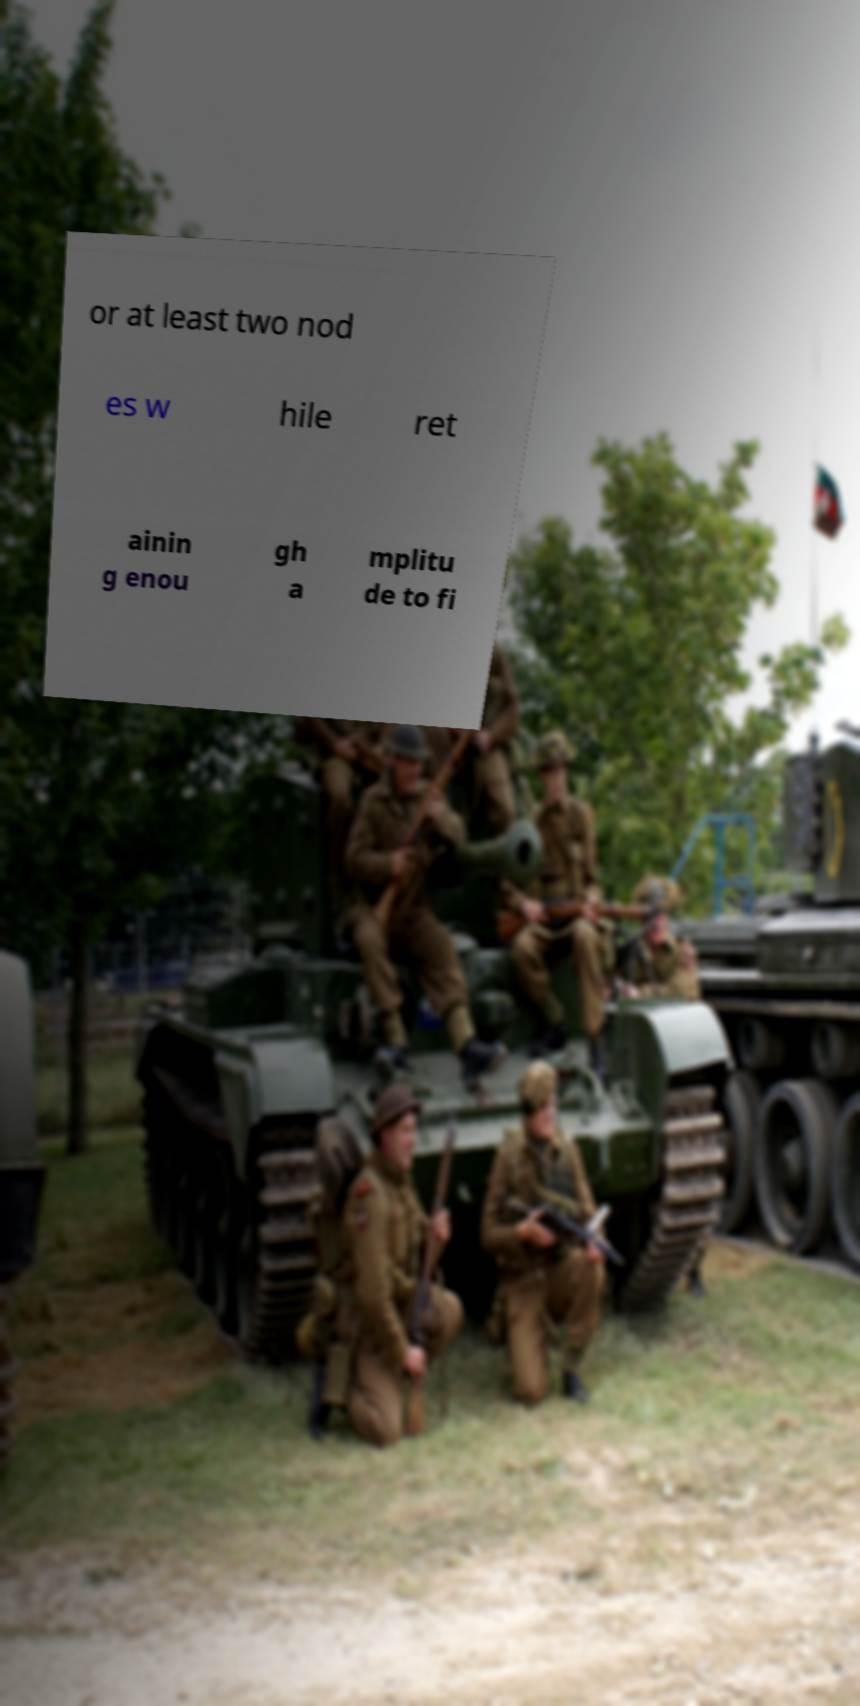For documentation purposes, I need the text within this image transcribed. Could you provide that? or at least two nod es w hile ret ainin g enou gh a mplitu de to fi 